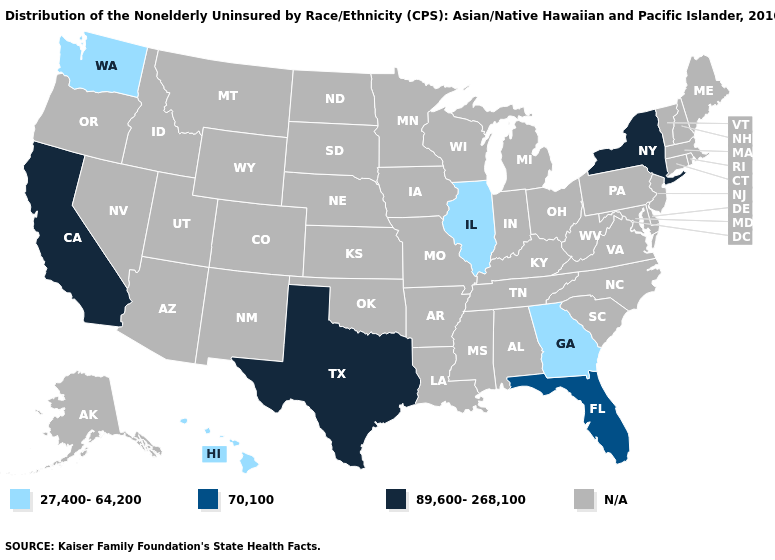Name the states that have a value in the range 89,600-268,100?
Write a very short answer. California, New York, Texas. Which states have the lowest value in the USA?
Quick response, please. Georgia, Hawaii, Illinois, Washington. What is the value of Kentucky?
Answer briefly. N/A. Name the states that have a value in the range 89,600-268,100?
Give a very brief answer. California, New York, Texas. What is the highest value in states that border Oregon?
Keep it brief. 89,600-268,100. Which states have the lowest value in the Northeast?
Keep it brief. New York. What is the value of South Dakota?
Quick response, please. N/A. What is the value of Kansas?
Short answer required. N/A. Name the states that have a value in the range 70,100?
Short answer required. Florida. What is the value of New Jersey?
Keep it brief. N/A. How many symbols are there in the legend?
Quick response, please. 4. Does Texas have the lowest value in the South?
Quick response, please. No. 